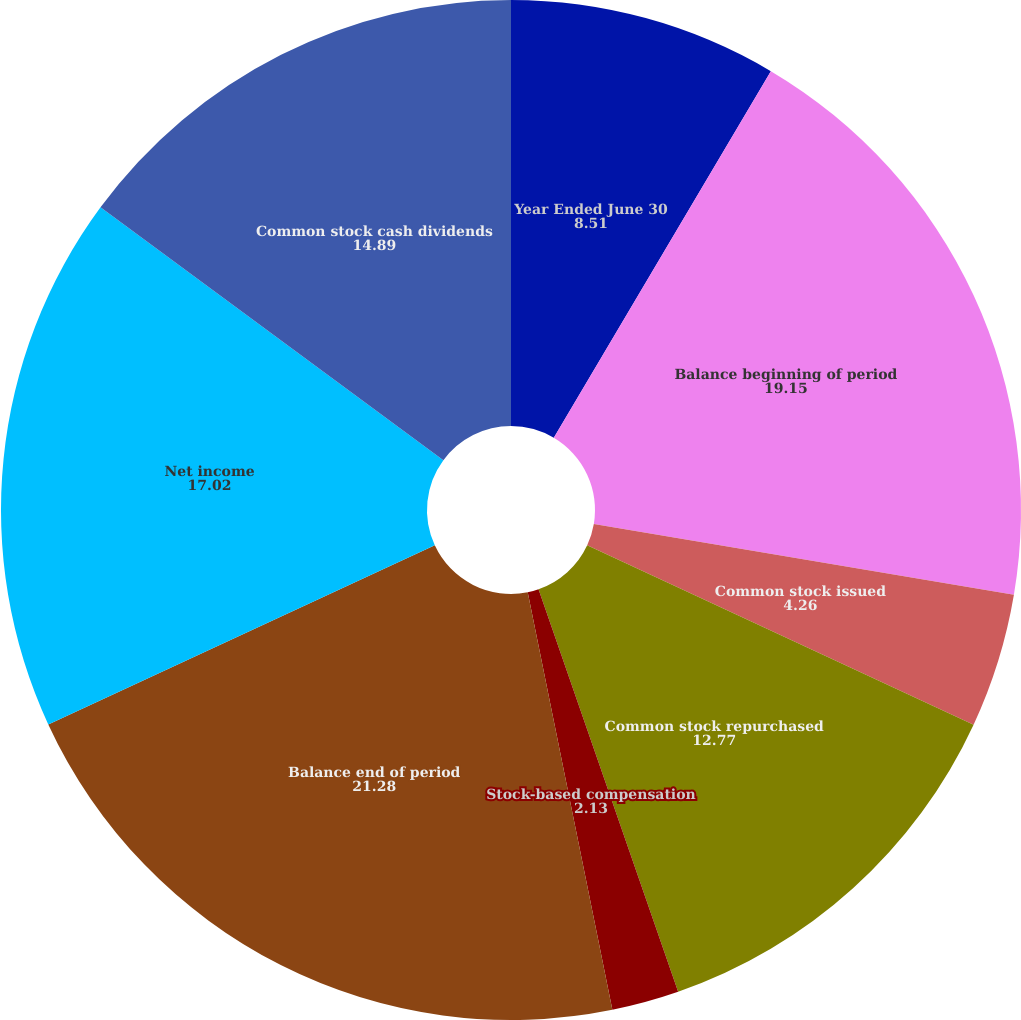Convert chart to OTSL. <chart><loc_0><loc_0><loc_500><loc_500><pie_chart><fcel>Year Ended June 30<fcel>Balance beginning of period<fcel>Common stock issued<fcel>Common stock repurchased<fcel>Stock-based compensation<fcel>Other net<fcel>Balance end of period<fcel>Net income<fcel>Common stock cash dividends<nl><fcel>8.51%<fcel>19.15%<fcel>4.26%<fcel>12.77%<fcel>2.13%<fcel>0.0%<fcel>21.28%<fcel>17.02%<fcel>14.89%<nl></chart> 